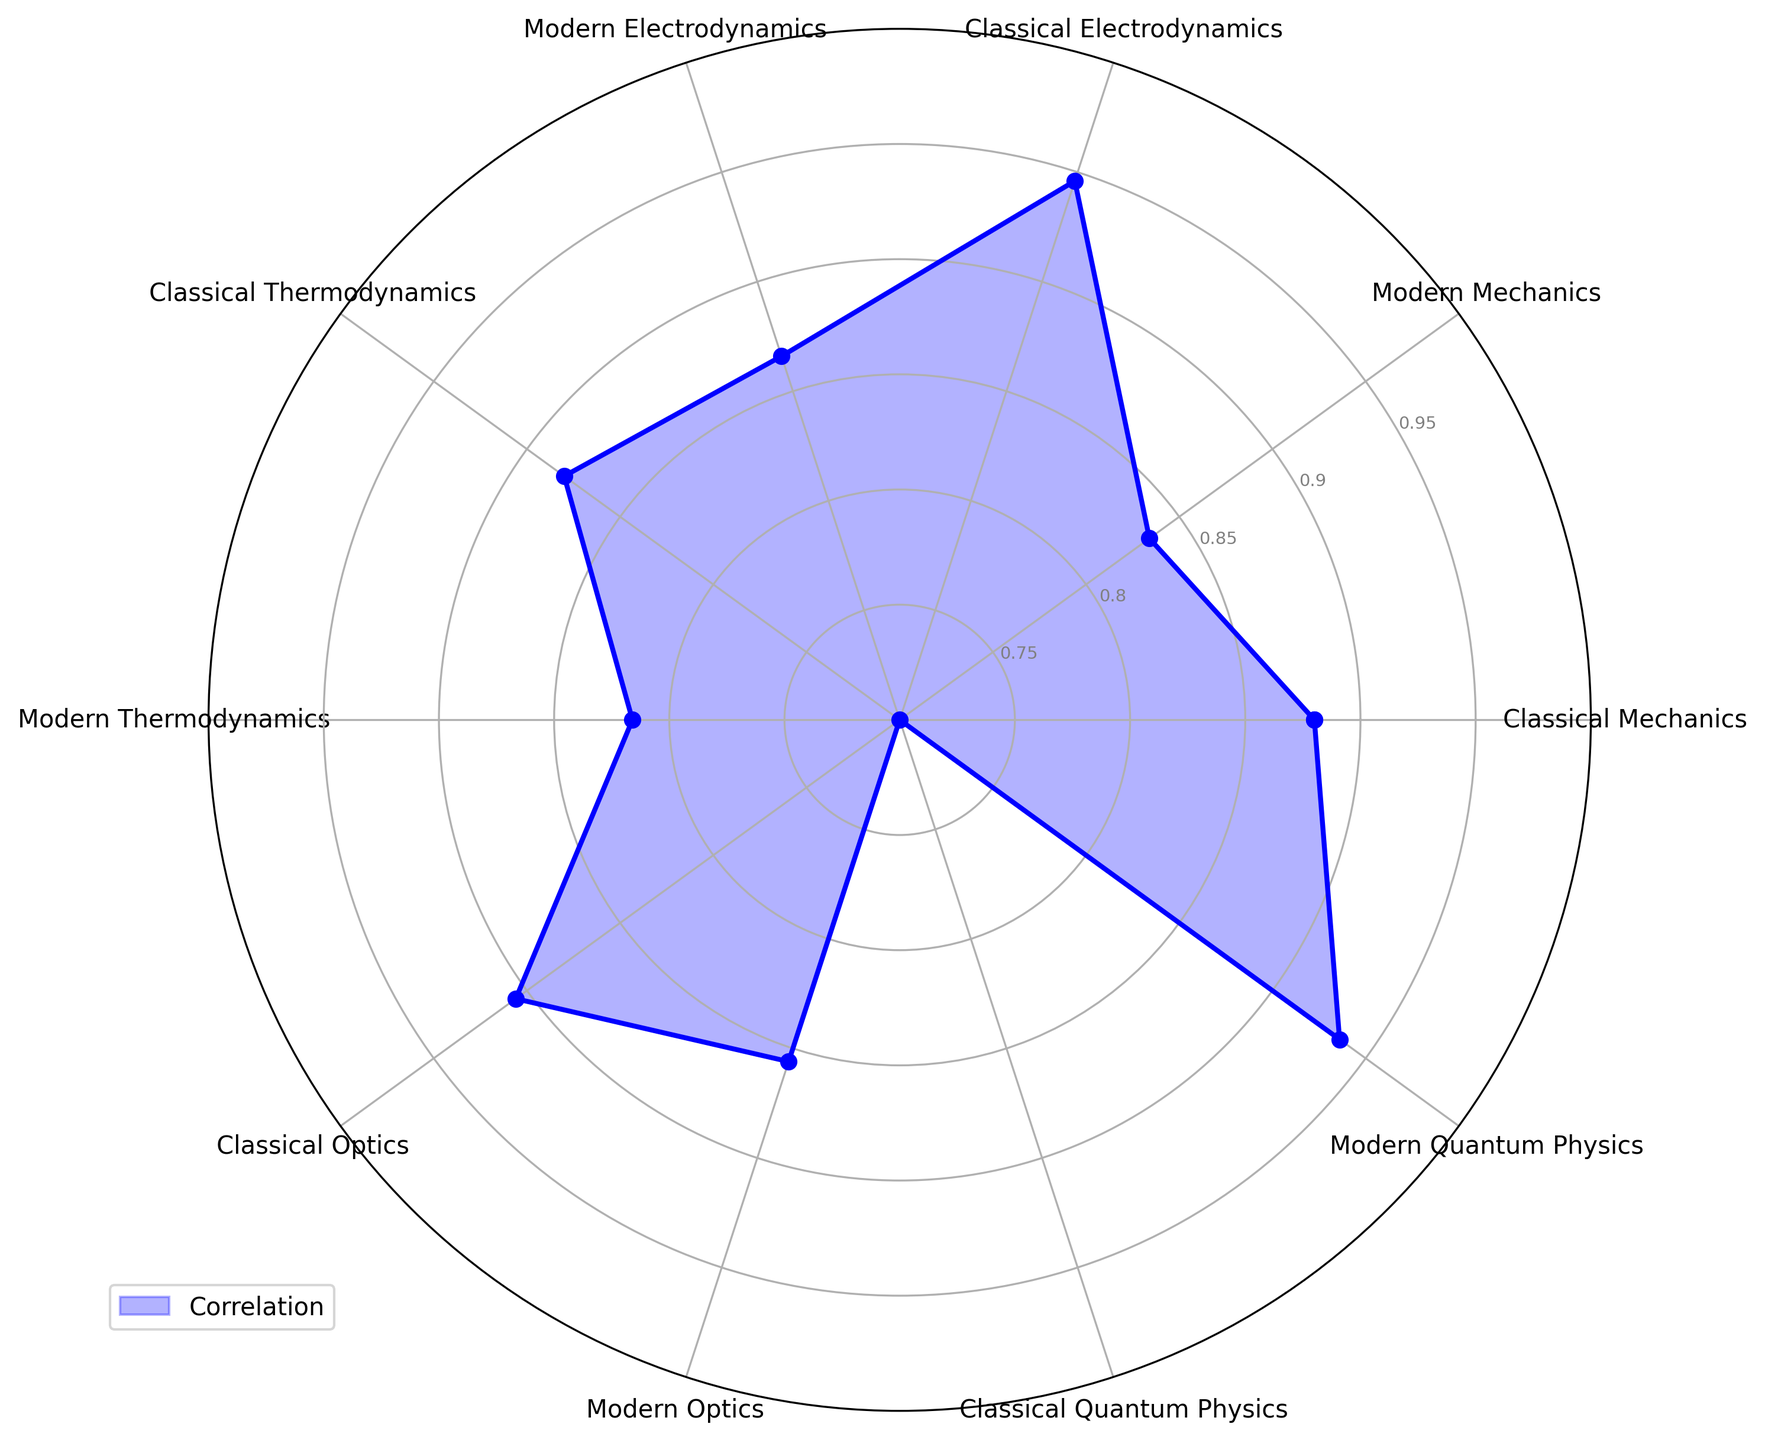Which subfield has the highest average correlation in modern physics? Calculate the average values for each subfield in modern physics by looking at 'Modern Mechanics', 'Modern Electrodynamics', 'Modern Thermodynamics', 'Modern Optics', and 'Modern Quantum Physics'. The highest value belongs to 'Modern Quantum Physics' averaging approximately 0.94.
Answer: Modern Quantum Physics Which subfield shows the biggest difference in average correlation between classical and modern physics? First, calculate the average correlation for each subfield in both classical and modern physics. Then, find the difference between classical and modern for each subfield. The largest difference is in 'Quantum Physics', where 'Modern Quantum Physics' at 0.94 and 'Classical Quantum Physics' at 0.7 show a difference of 0.24.
Answer: Quantum Physics Considering the correlations, which classical subfield consistently shows high correlation across the samples? Observing the mean values in the classical subfields, 'Classical Electrodynamics' consistently shows high correlation with values close to 0.95.
Answer: Classical Electrodynamics Comparing classical and modern optics, which exhibits a lower average correlation, and by how much? Calculate the averages for 'Classical Optics' and 'Modern Optics' from the samples. The average for 'Classical Optics' is slightly higher at 0.91 compared to 0.86 for 'Modern Optics', resulting in a difference of 0.05.
Answer: Modern Optics by 0.05 Which subfield shows the smallest difference in correlations between classical and modern physics? Compare the differences in the averages for each subfield between classical and modern physics. 'Mechanics' shows the smallest difference, with 'Classical Mechanics' at 0.88 and 'Modern Mechanics' at 0.83, resulting in a difference of just 0.05.
Answer: Mechanics 